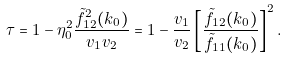<formula> <loc_0><loc_0><loc_500><loc_500>\tau = 1 - \eta _ { 0 } ^ { 2 } \frac { \tilde { f } _ { 1 2 } ^ { 2 } ( k _ { 0 } ) } { v _ { 1 } v _ { 2 } } = 1 - \frac { v _ { 1 } } { v _ { 2 } } \left [ \frac { \tilde { f } _ { 1 2 } ( k _ { 0 } ) } { \tilde { f } _ { 1 1 } ( k _ { 0 } ) } \right ] ^ { 2 } .</formula> 